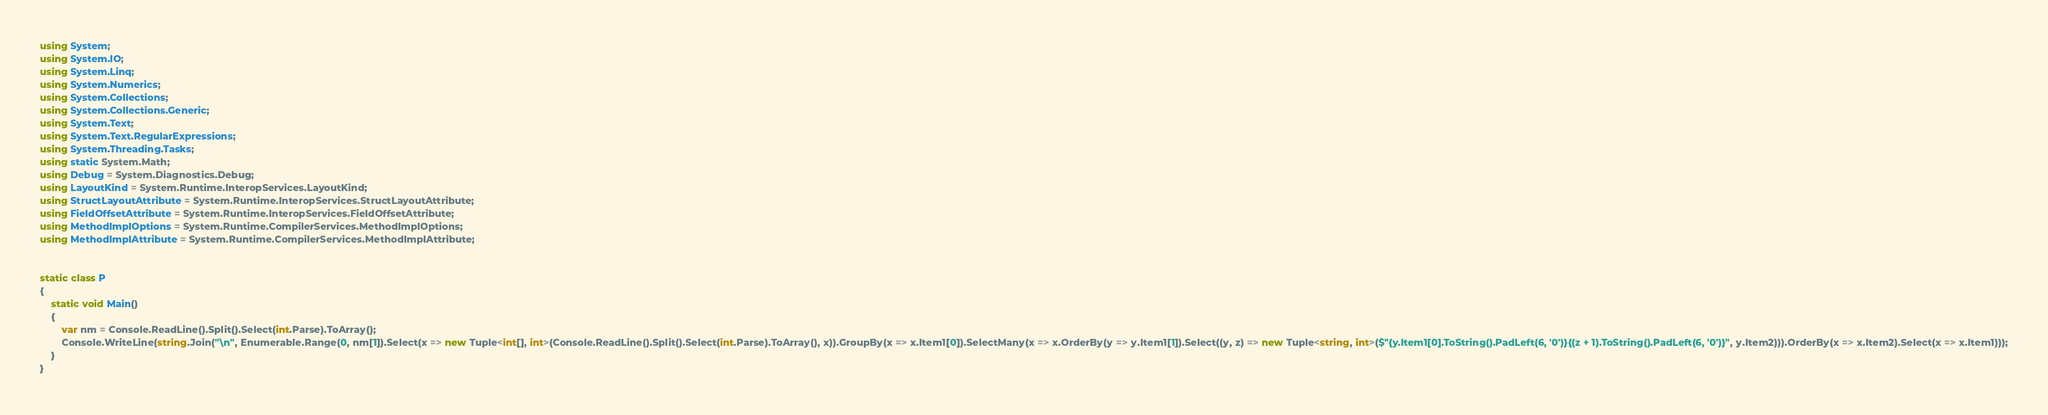Convert code to text. <code><loc_0><loc_0><loc_500><loc_500><_C#_>using System;
using System.IO;
using System.Linq;
using System.Numerics;
using System.Collections;
using System.Collections.Generic;
using System.Text;
using System.Text.RegularExpressions;
using System.Threading.Tasks;
using static System.Math;
using Debug = System.Diagnostics.Debug;
using LayoutKind = System.Runtime.InteropServices.LayoutKind;
using StructLayoutAttribute = System.Runtime.InteropServices.StructLayoutAttribute;
using FieldOffsetAttribute = System.Runtime.InteropServices.FieldOffsetAttribute;
using MethodImplOptions = System.Runtime.CompilerServices.MethodImplOptions;
using MethodImplAttribute = System.Runtime.CompilerServices.MethodImplAttribute;


static class P
{
    static void Main()
    {
        var nm = Console.ReadLine().Split().Select(int.Parse).ToArray();
        Console.WriteLine(string.Join("\n", Enumerable.Range(0, nm[1]).Select(x => new Tuple<int[], int>(Console.ReadLine().Split().Select(int.Parse).ToArray(), x)).GroupBy(x => x.Item1[0]).SelectMany(x => x.OrderBy(y => y.Item1[1]).Select((y, z) => new Tuple<string, int>($"{y.Item1[0].ToString().PadLeft(6, '0')}{(z + 1).ToString().PadLeft(6, '0')}", y.Item2))).OrderBy(x => x.Item2).Select(x => x.Item1)));
    }
}
</code> 